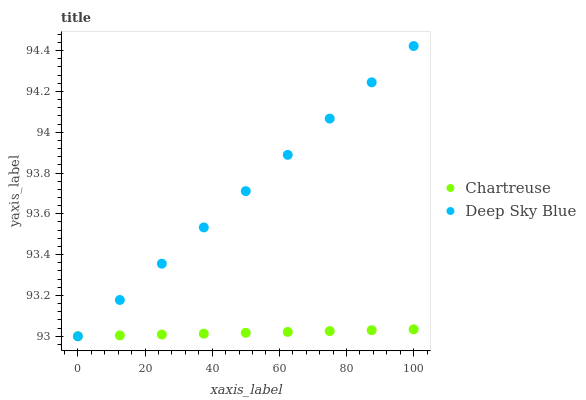Does Chartreuse have the minimum area under the curve?
Answer yes or no. Yes. Does Deep Sky Blue have the maximum area under the curve?
Answer yes or no. Yes. Does Deep Sky Blue have the minimum area under the curve?
Answer yes or no. No. Is Chartreuse the smoothest?
Answer yes or no. Yes. Is Deep Sky Blue the roughest?
Answer yes or no. Yes. Is Deep Sky Blue the smoothest?
Answer yes or no. No. Does Chartreuse have the lowest value?
Answer yes or no. Yes. Does Deep Sky Blue have the highest value?
Answer yes or no. Yes. Does Deep Sky Blue intersect Chartreuse?
Answer yes or no. Yes. Is Deep Sky Blue less than Chartreuse?
Answer yes or no. No. Is Deep Sky Blue greater than Chartreuse?
Answer yes or no. No. 